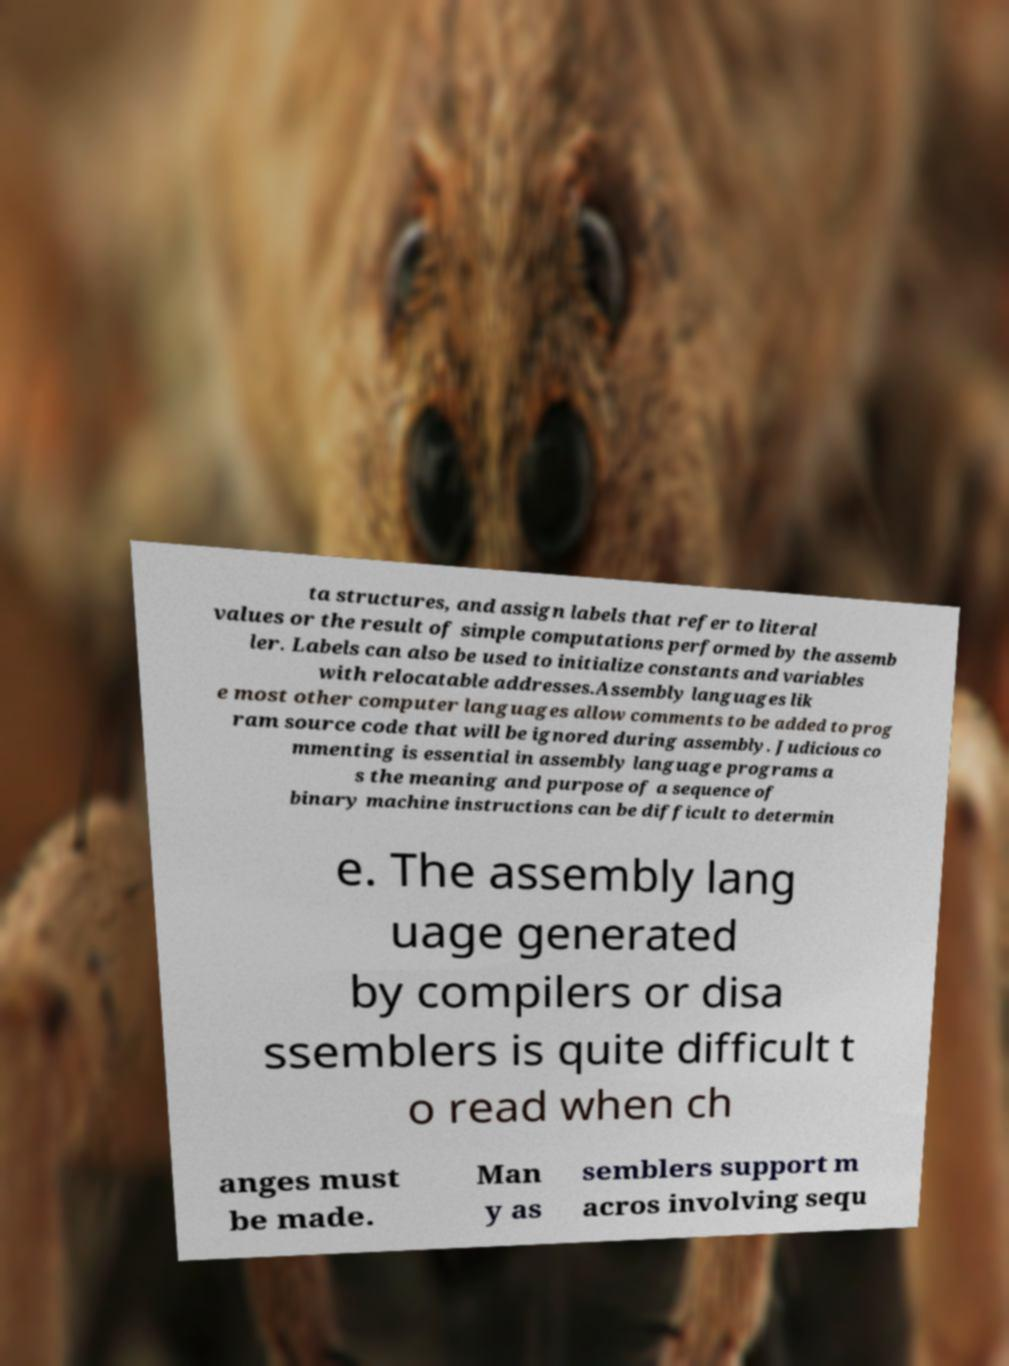Please read and relay the text visible in this image. What does it say? ta structures, and assign labels that refer to literal values or the result of simple computations performed by the assemb ler. Labels can also be used to initialize constants and variables with relocatable addresses.Assembly languages lik e most other computer languages allow comments to be added to prog ram source code that will be ignored during assembly. Judicious co mmenting is essential in assembly language programs a s the meaning and purpose of a sequence of binary machine instructions can be difficult to determin e. The assembly lang uage generated by compilers or disa ssemblers is quite difficult t o read when ch anges must be made. Man y as semblers support m acros involving sequ 